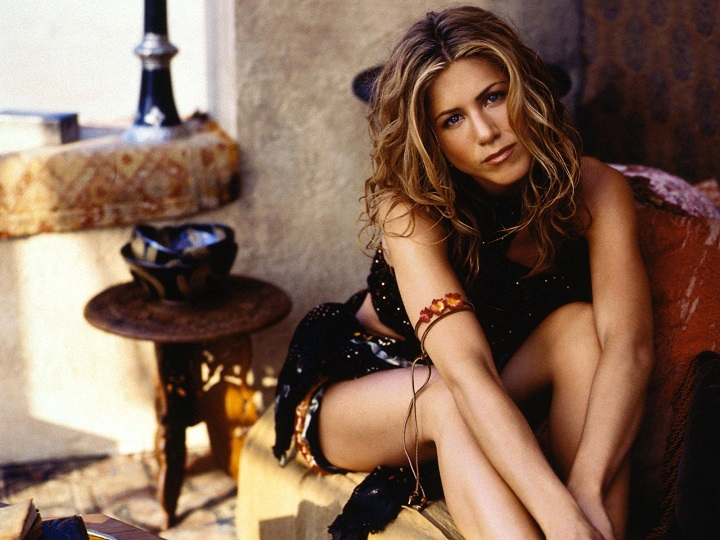What does the style of furniture and decor suggest about the geographical location where this photo might have been taken? The style of furniture and decor in the image, including the rustic wooden table, intricately patterned cushions, and the stucco wall, suggest it might be located in a region with a Mediterranean climate, such as Southern Europe or similar coastal areas. The warm hues and relaxed arrangement of the furniture connote a laid-back, sun-soaked lifestyle typical of Mediterranean locales. Details such as the small, ornate wooden table and warm, earthy tones further accentuate this aesthetic, hinting at a cultural appreciation for historic and artisanal craftsmanship found in these regions. 